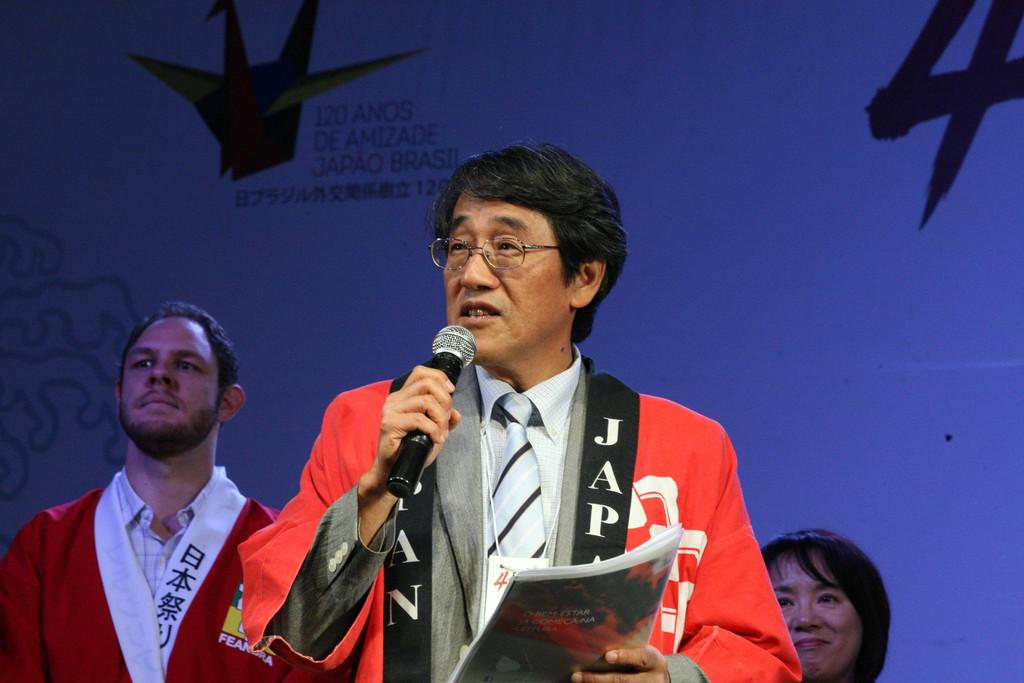<image>
Present a compact description of the photo's key features. A man speaking into a microphone has JAP on his lapel. 